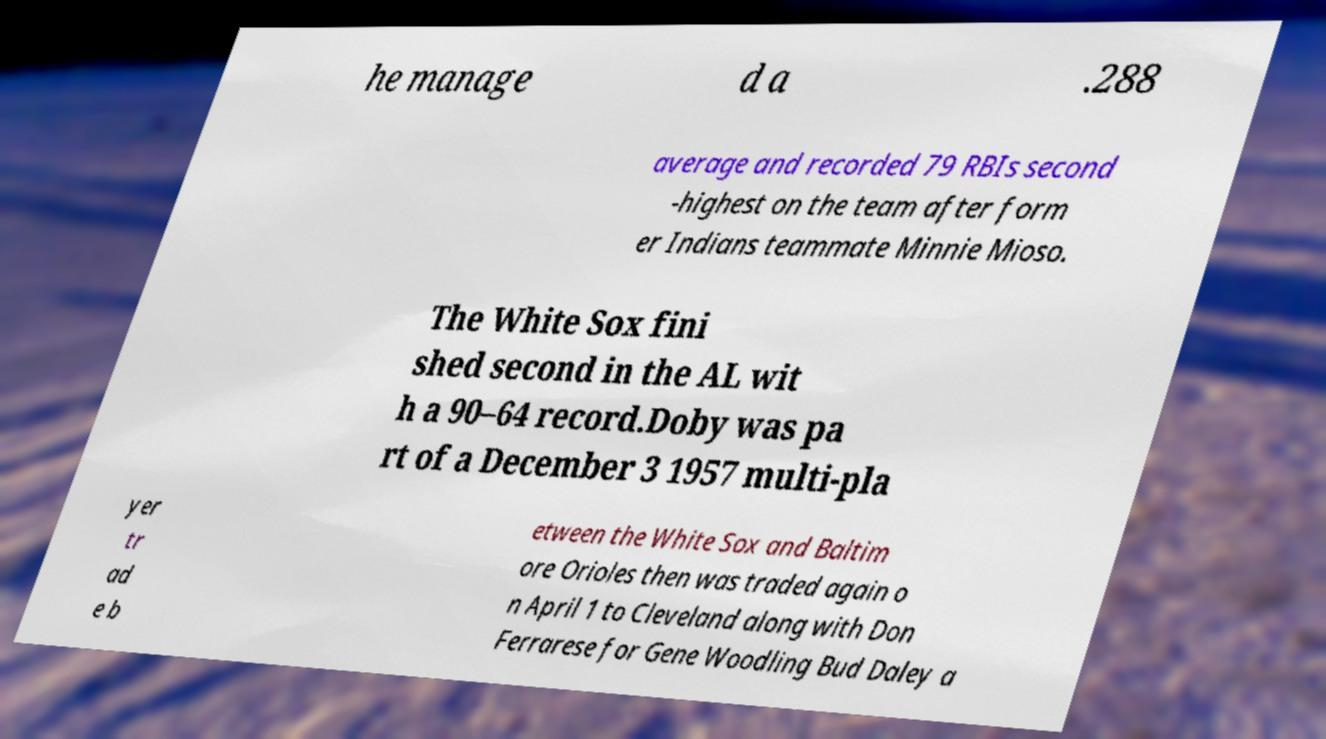Could you assist in decoding the text presented in this image and type it out clearly? he manage d a .288 average and recorded 79 RBIs second -highest on the team after form er Indians teammate Minnie Mioso. The White Sox fini shed second in the AL wit h a 90–64 record.Doby was pa rt of a December 3 1957 multi-pla yer tr ad e b etween the White Sox and Baltim ore Orioles then was traded again o n April 1 to Cleveland along with Don Ferrarese for Gene Woodling Bud Daley a 